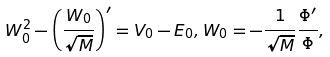Convert formula to latex. <formula><loc_0><loc_0><loc_500><loc_500>W _ { 0 } ^ { 2 } - \left ( \frac { W _ { 0 } } { \sqrt { M } } \right ) ^ { \prime } = V _ { 0 } - E _ { 0 } , W _ { 0 } = - \frac { 1 } { \sqrt { M } } \frac { \Phi ^ { \prime } } { \Phi } ,</formula> 